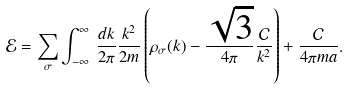<formula> <loc_0><loc_0><loc_500><loc_500>\mathcal { E } = \sum _ { \sigma } \int _ { - \infty } ^ { \infty } \, \frac { d k } { 2 \pi } \frac { k ^ { 2 } } { 2 m } \left ( \rho _ { \sigma } ( k ) - \frac { \sqrt { 3 } } { 4 \pi } \frac { \mathcal { C } } { k ^ { 2 } } \right ) + \frac { \mathcal { C } } { 4 \pi m a } .</formula> 